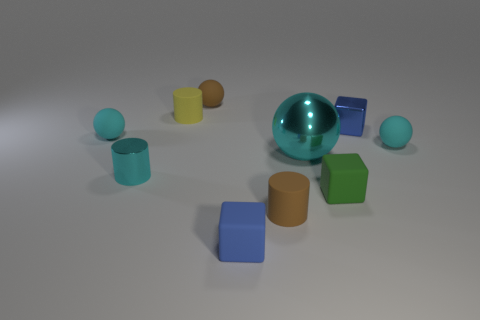There is another tiny block that is the same color as the small metal cube; what is it made of?
Keep it short and to the point. Rubber. There is a thing that is both behind the brown cylinder and in front of the small cyan metal thing; what shape is it?
Provide a succinct answer. Cube. There is a cylinder that is behind the small cyan object to the right of the small blue metal cube; what is its material?
Make the answer very short. Rubber. Are there more cylinders than small yellow objects?
Your answer should be compact. Yes. Do the big ball and the tiny metallic block have the same color?
Your answer should be very brief. No. There is a yellow object that is the same size as the green block; what is its material?
Provide a short and direct response. Rubber. Do the small brown cylinder and the large cyan sphere have the same material?
Your response must be concise. No. How many tiny objects are the same material as the large cyan sphere?
Make the answer very short. 2. How many objects are tiny objects that are behind the small green thing or shiny things that are behind the cyan metallic cylinder?
Keep it short and to the point. 7. Are there more tiny metallic cylinders in front of the tiny brown ball than metal objects behind the tiny yellow rubber object?
Offer a terse response. Yes. 